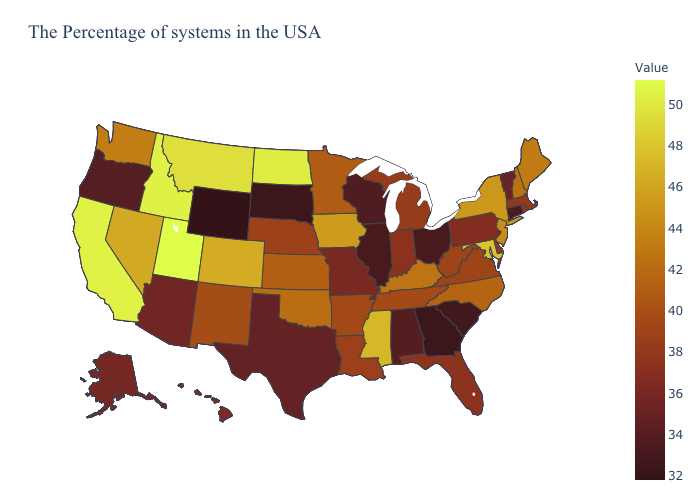Which states hav the highest value in the South?
Short answer required. Maryland. Does Nevada have a higher value than Utah?
Quick response, please. No. Which states have the lowest value in the USA?
Write a very short answer. Wyoming. Does Wyoming have the lowest value in the West?
Keep it brief. Yes. Which states have the highest value in the USA?
Give a very brief answer. Utah. Among the states that border Tennessee , does Missouri have the lowest value?
Write a very short answer. No. Among the states that border Indiana , which have the lowest value?
Concise answer only. Ohio, Illinois. Does the map have missing data?
Write a very short answer. No. 